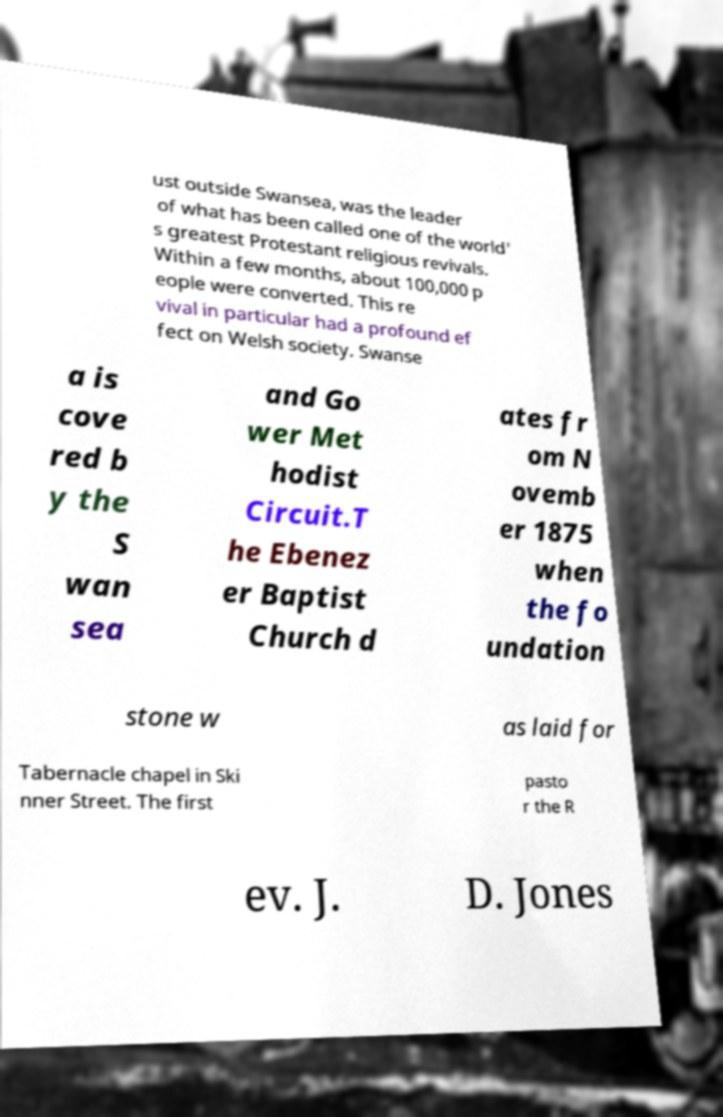Can you read and provide the text displayed in the image?This photo seems to have some interesting text. Can you extract and type it out for me? ust outside Swansea, was the leader of what has been called one of the world' s greatest Protestant religious revivals. Within a few months, about 100,000 p eople were converted. This re vival in particular had a profound ef fect on Welsh society. Swanse a is cove red b y the S wan sea and Go wer Met hodist Circuit.T he Ebenez er Baptist Church d ates fr om N ovemb er 1875 when the fo undation stone w as laid for Tabernacle chapel in Ski nner Street. The first pasto r the R ev. J. D. Jones 